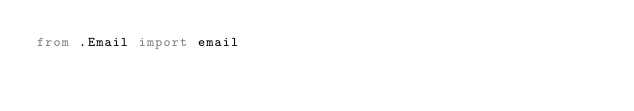<code> <loc_0><loc_0><loc_500><loc_500><_Python_>from .Email import email
</code> 